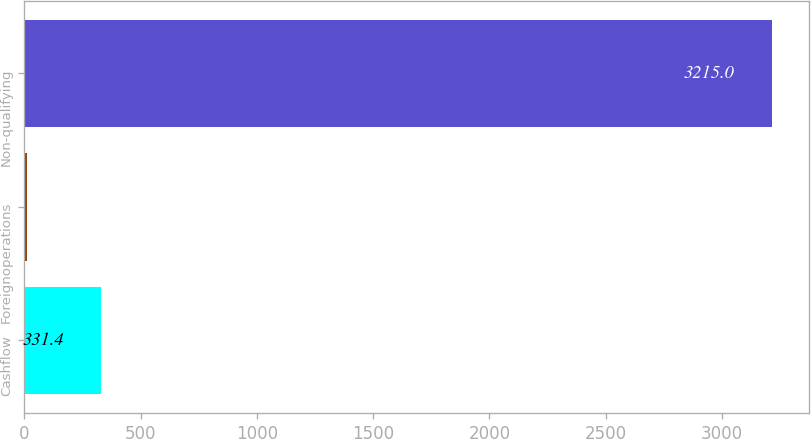<chart> <loc_0><loc_0><loc_500><loc_500><bar_chart><fcel>Cashflow<fcel>Foreignoperations<fcel>Non-qualifying<nl><fcel>331.4<fcel>11<fcel>3215<nl></chart> 